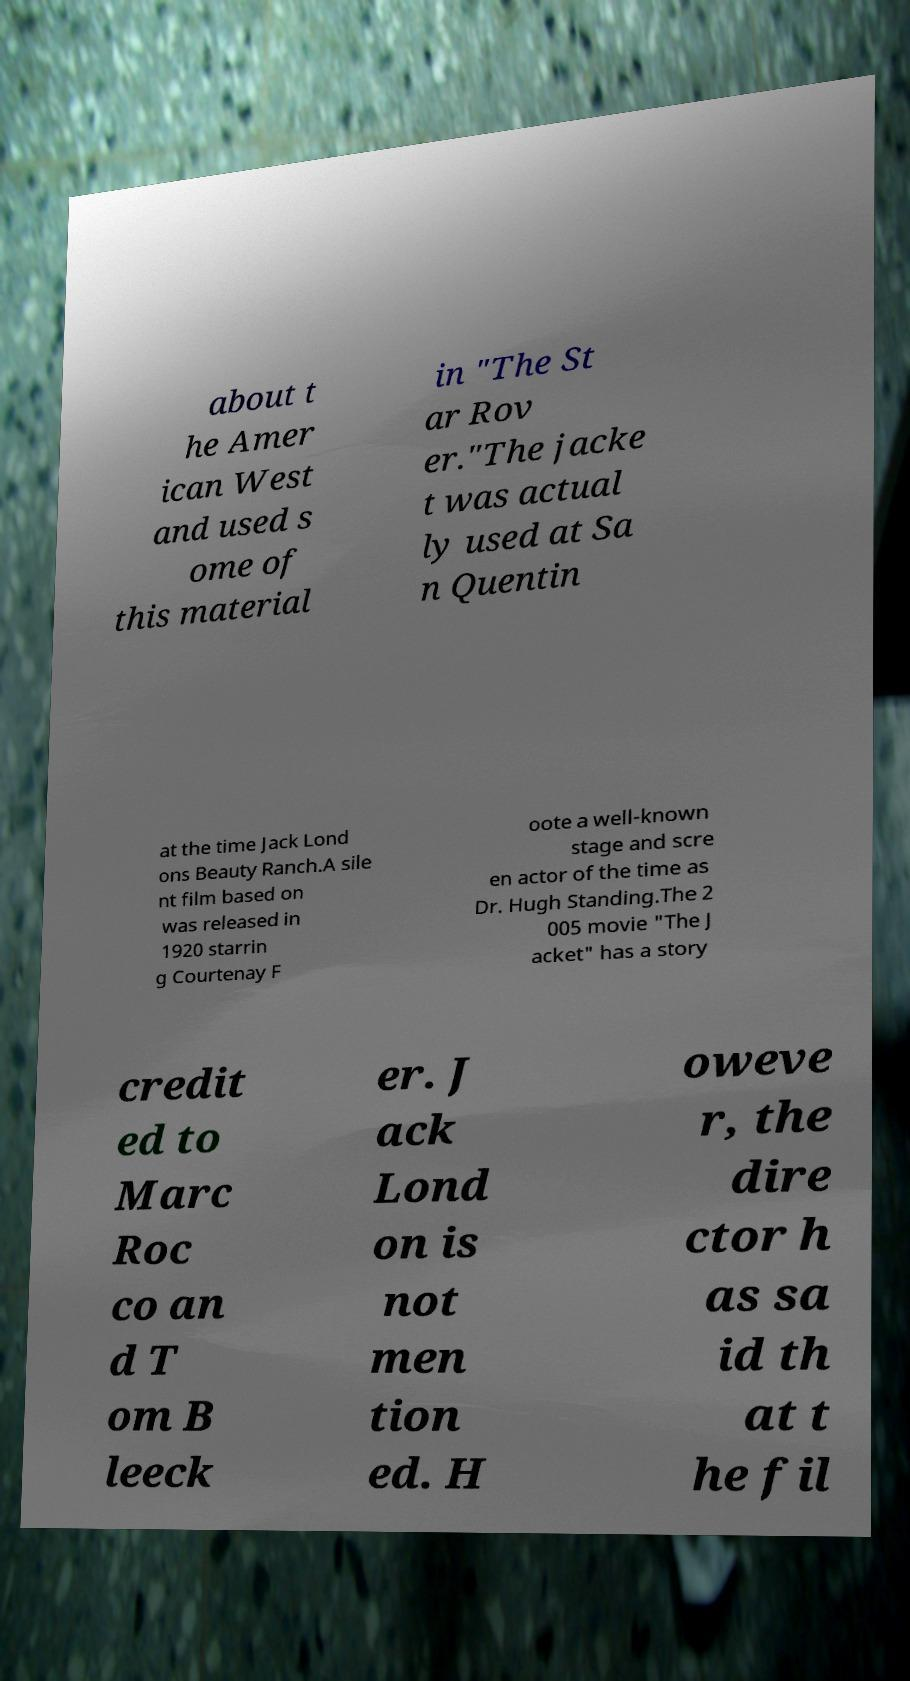Can you accurately transcribe the text from the provided image for me? about t he Amer ican West and used s ome of this material in "The St ar Rov er."The jacke t was actual ly used at Sa n Quentin at the time Jack Lond ons Beauty Ranch.A sile nt film based on was released in 1920 starrin g Courtenay F oote a well-known stage and scre en actor of the time as Dr. Hugh Standing.The 2 005 movie "The J acket" has a story credit ed to Marc Roc co an d T om B leeck er. J ack Lond on is not men tion ed. H oweve r, the dire ctor h as sa id th at t he fil 